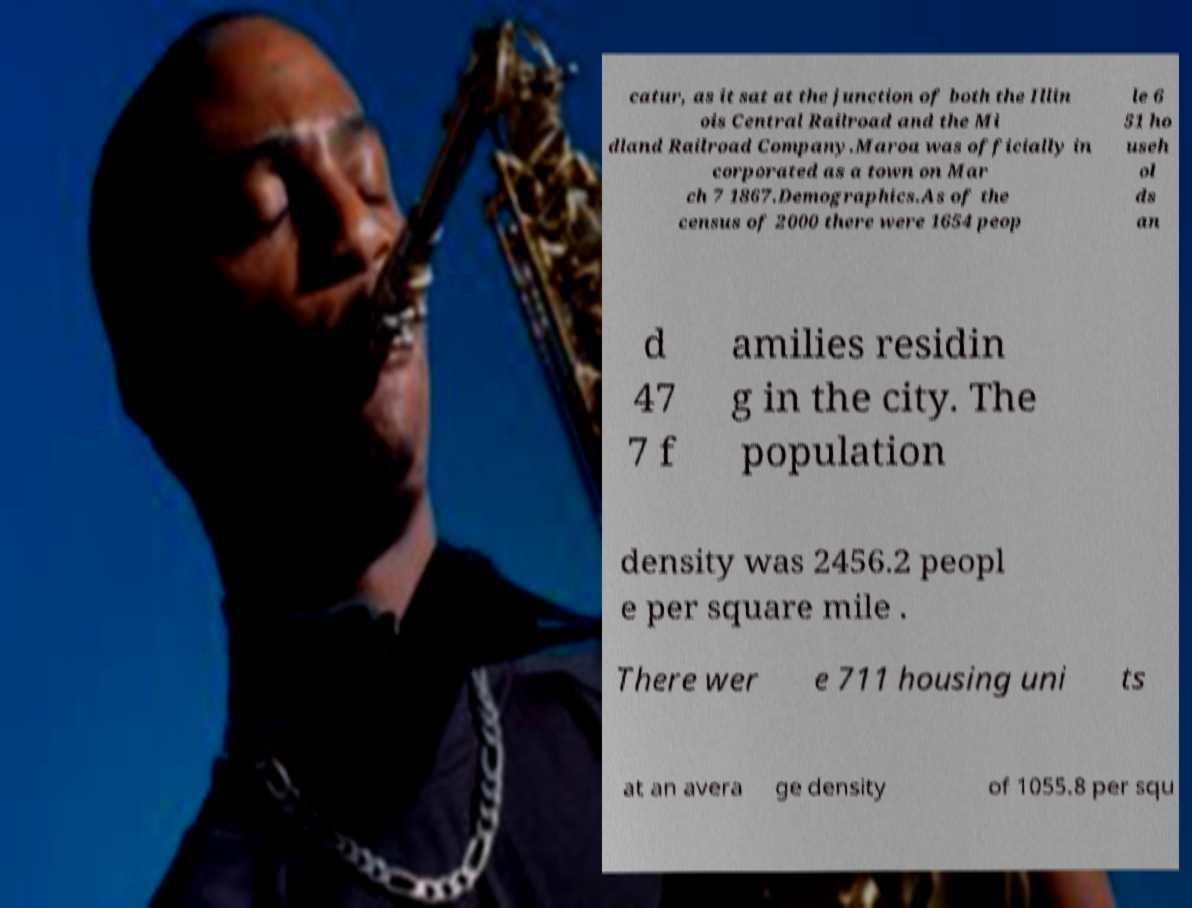I need the written content from this picture converted into text. Can you do that? catur, as it sat at the junction of both the Illin ois Central Railroad and the Mi dland Railroad Company.Maroa was officially in corporated as a town on Mar ch 7 1867.Demographics.As of the census of 2000 there were 1654 peop le 6 51 ho useh ol ds an d 47 7 f amilies residin g in the city. The population density was 2456.2 peopl e per square mile . There wer e 711 housing uni ts at an avera ge density of 1055.8 per squ 